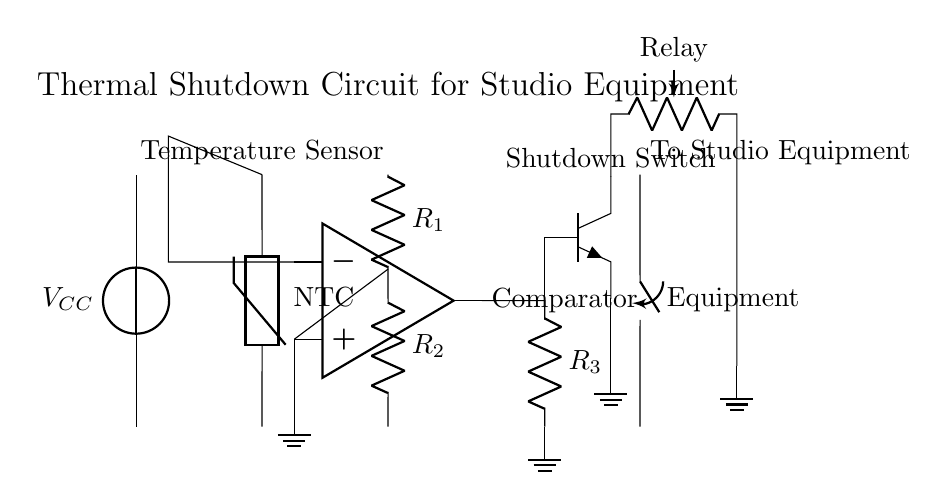What type of thermistor is used in this circuit? The circuit uses an NTC thermistor, which is indicated by the label on the thermistor symbol. NTC stands for Negative Temperature Coefficient, meaning its resistance decreases as the temperature increases.
Answer: NTC What is the function of the comparator in this circuit? The comparator compares the voltage from the voltage divider created by R1 and R2 with the voltage from the NTC thermistor. When the temperature crosses a certain threshold, it changes state to activate the shutdown mechanism.
Answer: Compare voltage What component is used to relay the shutdown signal? The relay is used for relaying the shutdown signal, acting as a switch to disconnect the studio equipment when overheating is detected. This is shown by the relay symbol connected to the output of the comparator.
Answer: Relay What happens at the output of the op-amp when the temperature exceeds the threshold? When the temperature exceeds the threshold, the output of the op-amp goes high, activating the relay, which opens the shutdown switch and disconnects the studio equipment. This behavior is a key function of the thermal shutdown mechanism.
Answer: Output goes high What is the connection from the comparator’s output to the shutdown switch? The output from the comparator connects to the base of an npn transistor, which controls the relay that disconnects the equipment, forming a crucial part of the shutdown process.
Answer: npn transistor How many resistors are present in the voltage reference section? There are two resistors (R1 and R2) in the voltage reference section, which form a voltage divider to set the reference voltage for the comparator's positive input.
Answer: Two resistors 